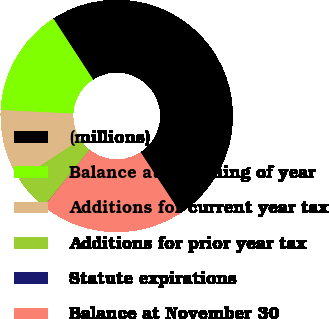<chart> <loc_0><loc_0><loc_500><loc_500><pie_chart><fcel>(millions)<fcel>Balance at beginning of year<fcel>Additions for current year tax<fcel>Additions for prior year tax<fcel>Statute expirations<fcel>Balance at November 30<nl><fcel>49.94%<fcel>15.0%<fcel>10.01%<fcel>5.02%<fcel>0.03%<fcel>19.99%<nl></chart> 